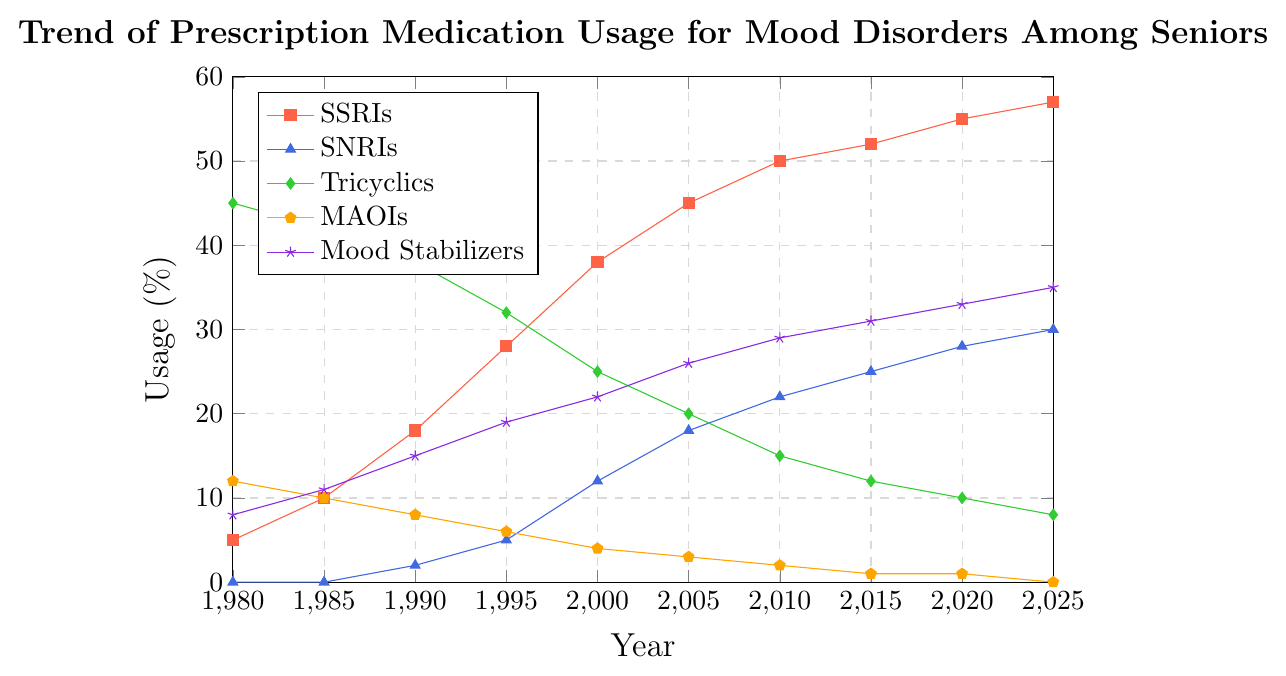What was the percentage change in SSRIs usage from 1980 to 2025? To find the percentage change, we use the formula: ((new_value - old_value) / old_value) * 100. Here, the values are 57 (2025) and 5 (1980). Thus, ((57 - 5) / 5) * 100 = 1040%.
Answer: 1040% Which type of medication showed the largest increase in usage from 1980 to 2025? By visually inspecting the chart, we observe that SSRIs increased from 5% to 57%, SNRIs from 0% to 30%, Tricyclics decreased from 45% to 8%, MAOIs decreased from 12% to 0%, and Mood Stabilizers increased from 8% to 35%. SSRIs increased the most.
Answer: SSRIs In which years did SSRIs usage surpass Tricyclics usage? Visually trace the lines for SSRIs and Tricyclics. SSRIs surpass Tricyclics between 1995 and 2000. So, the specific years are 2000, 2005, 2010, 2015, 2020, and 2025.
Answer: 2000, 2005, 2010, 2015, 2020, 2025 What was the usage percentage of MAOIs in 2005 and how much did it differ from its usage in 1980? MAOIs usage in 2005 is 3%. In 1980, it was 12%. The difference is 12% - 3% = 9%.
Answer: 9% Which year saw Mood Stabilizers usage reach 35%? Look at the plot line for Mood Stabilizers and find where it reaches 35%. The year is 2025.
Answer: 2025 How many years after 1980 did SNRIs start being used? SNRIs start being used in 1990. Thus, 1990 - 1980 = 10 years.
Answer: 10 years Compare the usage trends of SSRIs and Mood Stabilizers between 1980 and 2020. Which one grew faster? SSRIs grew from 5% to 55%, and Mood Stabilizers grew from 8% to 33%. The growth for SSRIs is 55% - 5% = 50%, while for Mood Stabilizers it is 33% - 8% = 25%. SSRIs grew faster.
Answer: SSRIs Which medication type had its usage drop to zero by 2025? By examining each plot line, it is evident that MAOIs dropped to 0% by 2025.
Answer: MAOIs 